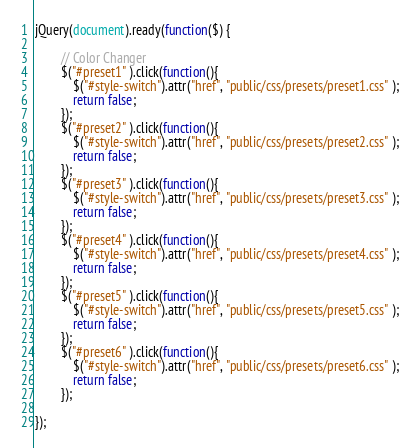Convert code to text. <code><loc_0><loc_0><loc_500><loc_500><_JavaScript_>jQuery(document).ready(function($) {
	
		// Color Changer
		$("#preset1" ).click(function(){
			$("#style-switch").attr("href", "public/css/presets/preset1.css" );
			return false;
		});
		$("#preset2" ).click(function(){
			$("#style-switch").attr("href", "public/css/presets/preset2.css" );
			return false;
		});
		$("#preset3" ).click(function(){
			$("#style-switch").attr("href", "public/css/presets/preset3.css" );
			return false;
		});
		$("#preset4" ).click(function(){
			$("#style-switch").attr("href", "public/css/presets/preset4.css" );
			return false;
		});
		$("#preset5" ).click(function(){
			$("#style-switch").attr("href", "public/css/presets/preset5.css" );
			return false;
		});
		$("#preset6" ).click(function(){
			$("#style-switch").attr("href", "public/css/presets/preset6.css" );
			return false;
		});

});</code> 